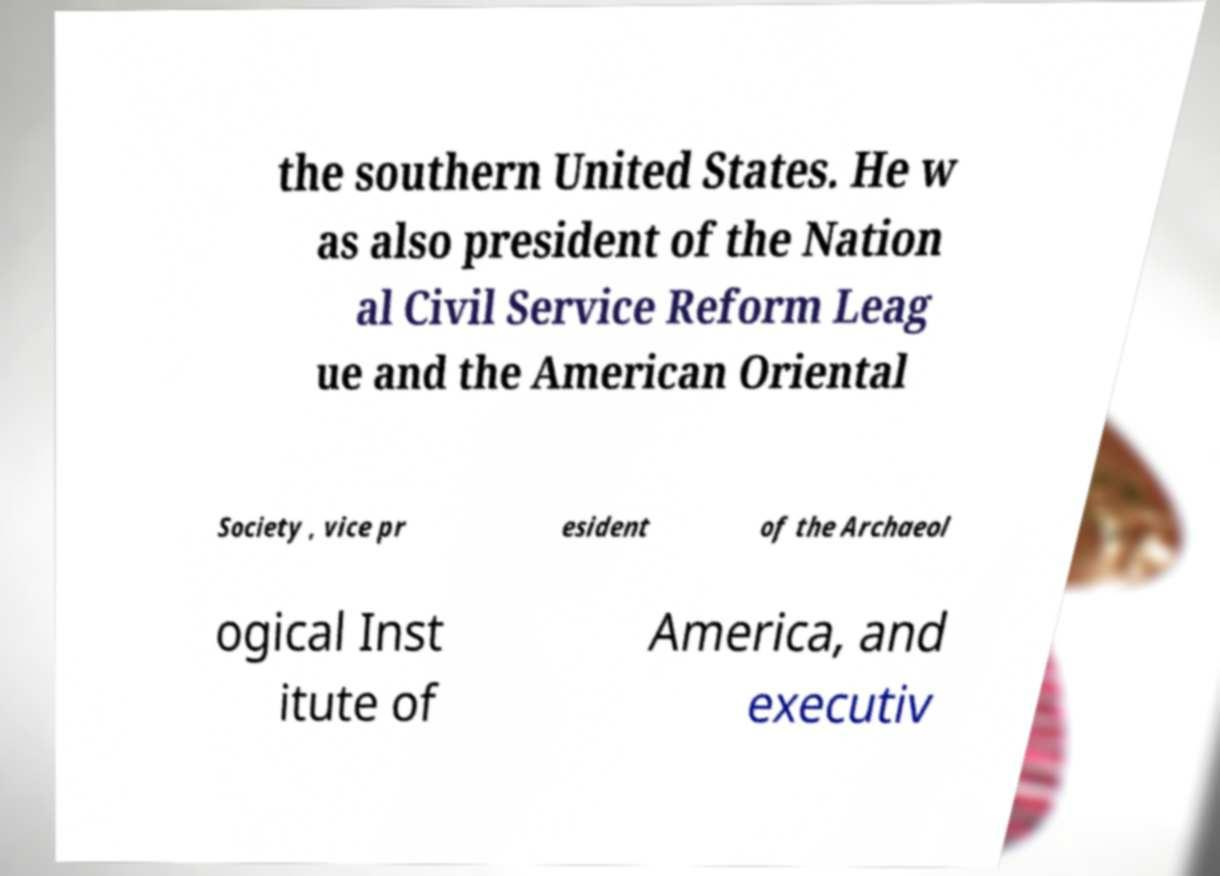For documentation purposes, I need the text within this image transcribed. Could you provide that? the southern United States. He w as also president of the Nation al Civil Service Reform Leag ue and the American Oriental Society , vice pr esident of the Archaeol ogical Inst itute of America, and executiv 